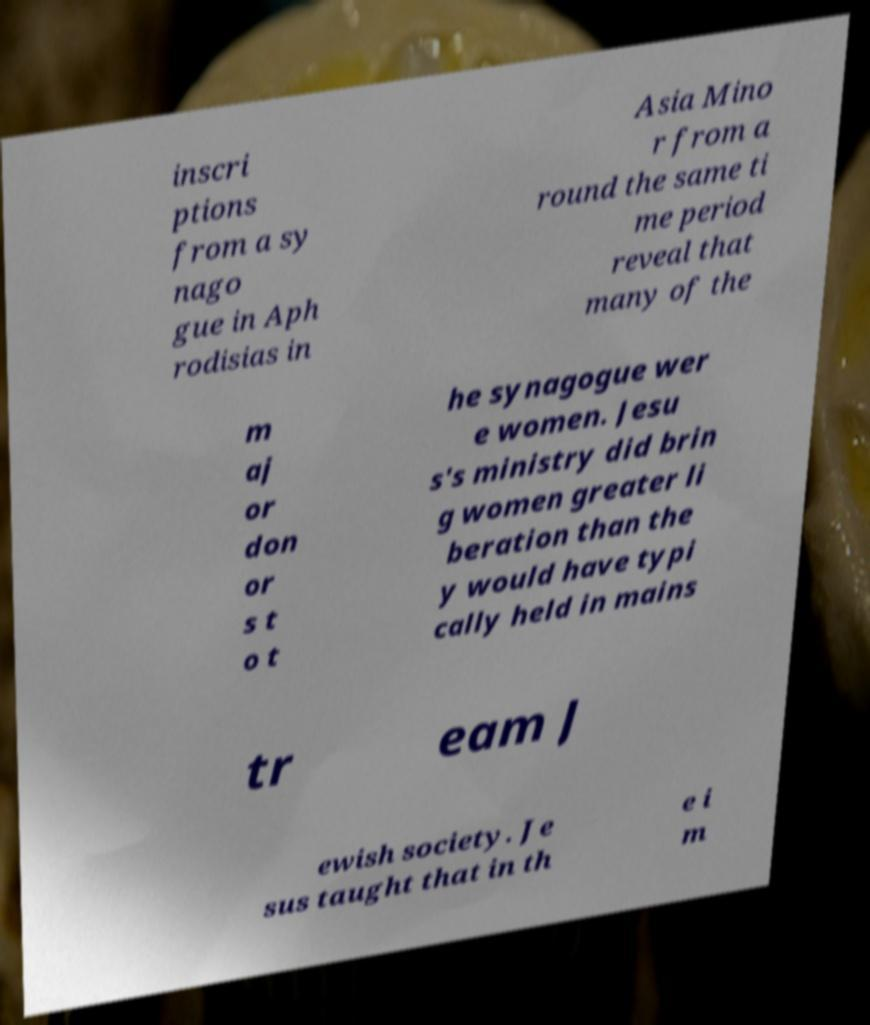Please identify and transcribe the text found in this image. inscri ptions from a sy nago gue in Aph rodisias in Asia Mino r from a round the same ti me period reveal that many of the m aj or don or s t o t he synagogue wer e women. Jesu s's ministry did brin g women greater li beration than the y would have typi cally held in mains tr eam J ewish society. Je sus taught that in th e i m 